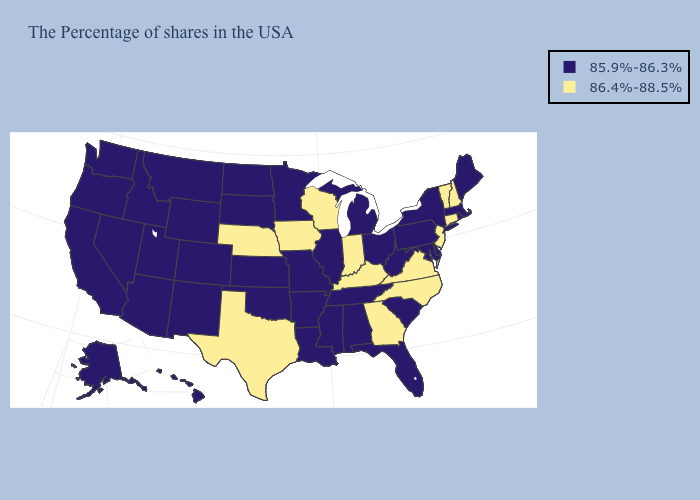Does the first symbol in the legend represent the smallest category?
Short answer required. Yes. What is the value of Wyoming?
Short answer required. 85.9%-86.3%. What is the value of Virginia?
Be succinct. 86.4%-88.5%. Does Nebraska have the lowest value in the MidWest?
Quick response, please. No. Which states have the lowest value in the USA?
Give a very brief answer. Maine, Massachusetts, Rhode Island, New York, Delaware, Maryland, Pennsylvania, South Carolina, West Virginia, Ohio, Florida, Michigan, Alabama, Tennessee, Illinois, Mississippi, Louisiana, Missouri, Arkansas, Minnesota, Kansas, Oklahoma, South Dakota, North Dakota, Wyoming, Colorado, New Mexico, Utah, Montana, Arizona, Idaho, Nevada, California, Washington, Oregon, Alaska, Hawaii. What is the lowest value in states that border Illinois?
Give a very brief answer. 85.9%-86.3%. Which states have the lowest value in the Northeast?
Short answer required. Maine, Massachusetts, Rhode Island, New York, Pennsylvania. Does Nebraska have the highest value in the MidWest?
Concise answer only. Yes. How many symbols are there in the legend?
Write a very short answer. 2. What is the value of Kansas?
Short answer required. 85.9%-86.3%. What is the highest value in the USA?
Give a very brief answer. 86.4%-88.5%. Among the states that border North Carolina , which have the lowest value?
Short answer required. South Carolina, Tennessee. Name the states that have a value in the range 85.9%-86.3%?
Concise answer only. Maine, Massachusetts, Rhode Island, New York, Delaware, Maryland, Pennsylvania, South Carolina, West Virginia, Ohio, Florida, Michigan, Alabama, Tennessee, Illinois, Mississippi, Louisiana, Missouri, Arkansas, Minnesota, Kansas, Oklahoma, South Dakota, North Dakota, Wyoming, Colorado, New Mexico, Utah, Montana, Arizona, Idaho, Nevada, California, Washington, Oregon, Alaska, Hawaii. What is the highest value in the USA?
Be succinct. 86.4%-88.5%. How many symbols are there in the legend?
Answer briefly. 2. 